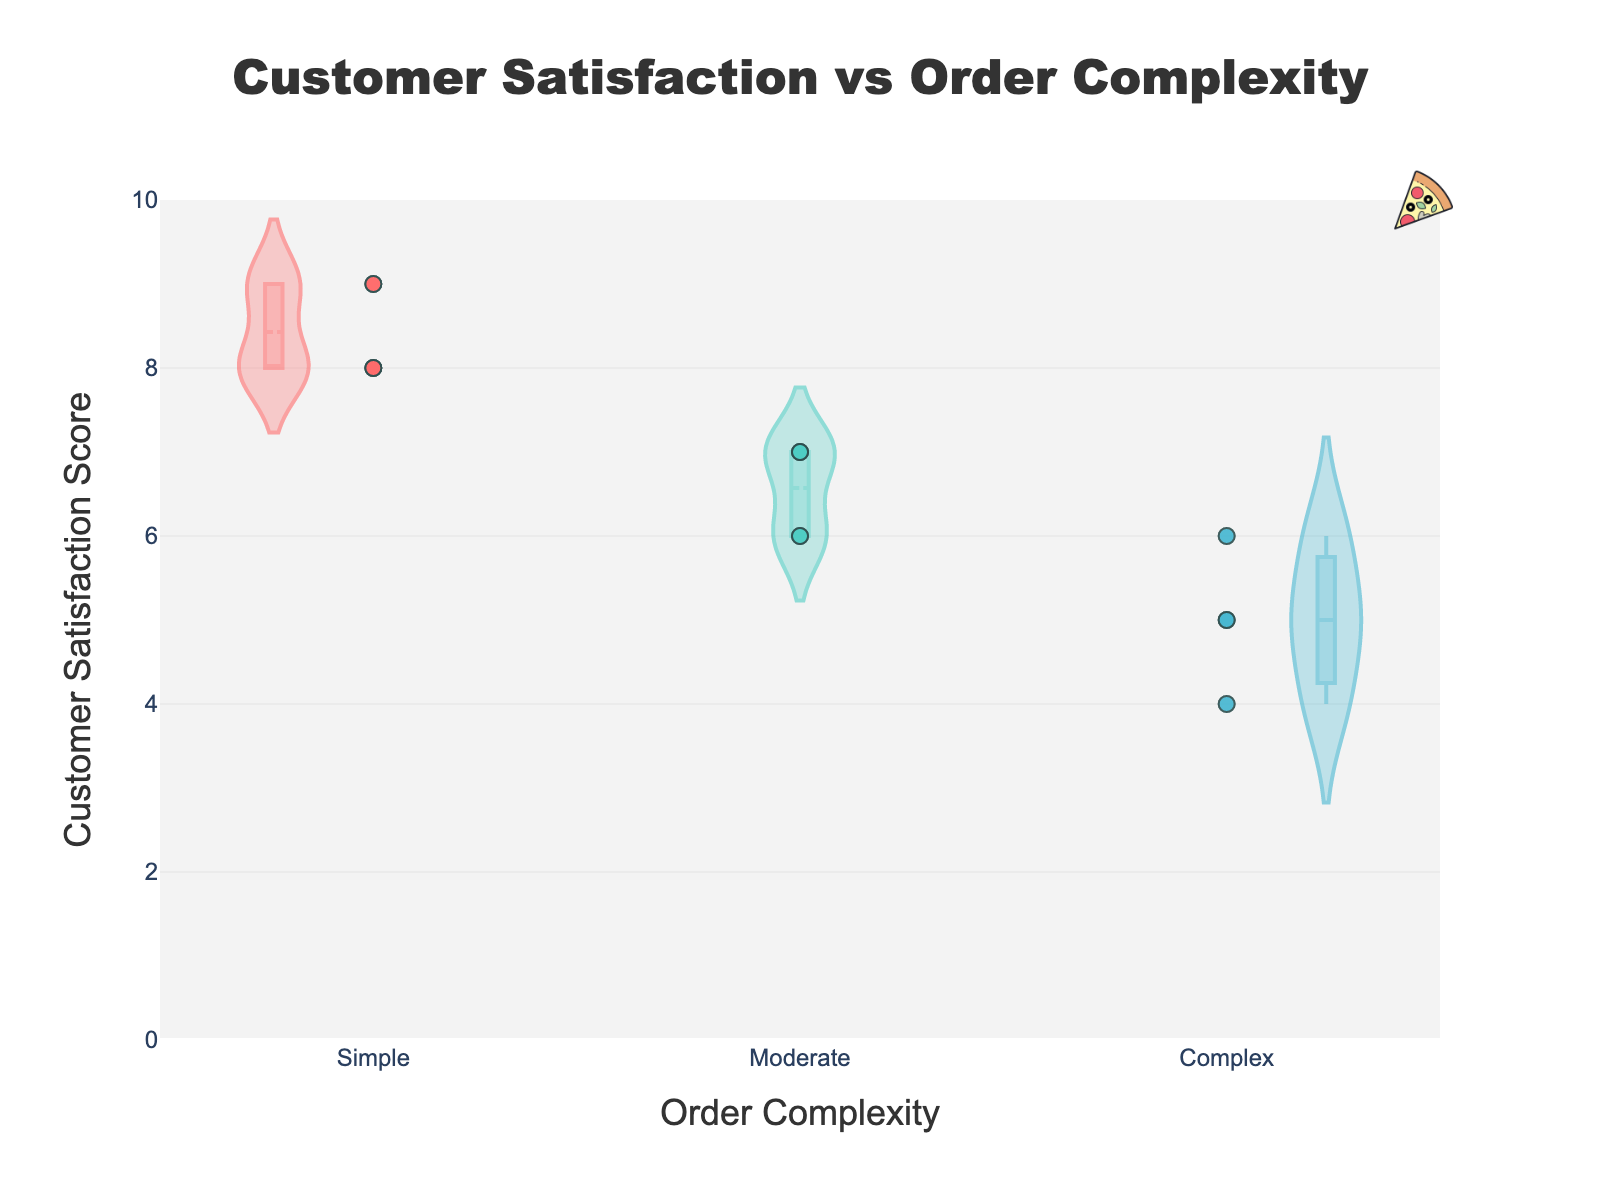What is the title of the chart? The title is usually found at the top of the chart, and in this case, it reads "Customer Satisfaction vs Order Complexity"
Answer: Customer Satisfaction vs Order Complexity What are the three categories of Order Complexity present in the chart? By looking at the different sections along the x-axis, you will see labels for each category which includes "Simple," "Moderate," and "Complex"
Answer: Simple, Moderate, Complex Which Order Complexity appears to have the highest median customer satisfaction score? In violin plots, the median is often represented by a thicker line inside the plot. By visually comparing the plots, "Simple" shows the highest line
Answer: Simple What is the general trend in customer satisfaction as Order Complexity increases from Simple to Complex? By comparing the overall shape and spread of the violin plots from Simple to Complex, it is evident that the median and density of higher scores decrease as Order Complexity increases
Answer: Satisfaction decreases How many data points are there in the "Moderate" category? The number of data points can be counted by looking at the jittered points within the "Moderate" section of the violin plot. Counting these points will give the answer
Answer: 7 Which Order Complexity has the widest spread in customer satisfaction scores? The spread can be assessed by looking at the width of the violin plots—"Complex" has the widest spread ranging from low to high scores
Answer: Complex What is the color associated with the "Complex" Order Complexity in the chart? The colors are mapped to each Order Complexity. The "Complex" category is colored with a shade of blue which is a distinct color from the other categories
Answer: Blue By approximately how many points does the median customer satisfaction for "Moderate" orders differ from "Complex" orders? The median for "Moderate" orders is around 6.5-7, while for "Complex" orders, it is around 5.5. Subtracting these gives a difference of around 1-1.5 points
Answer: 1-1.5 points Which Order Complexity shows the smallest variation in customer satisfaction scores? By comparing the density spread of each violin plot, "Simple" has the smallest variation, indicated by a concentrated and less spread-out shape
Answer: Simple If you were to aim for consistent high customer satisfaction, which Order Complexity would be preferable based on this plot? Observing the median and density of high satisfaction scores, "Simple" would be preferable as it shows the highest and most consistent satisfaction scores
Answer: Simple 